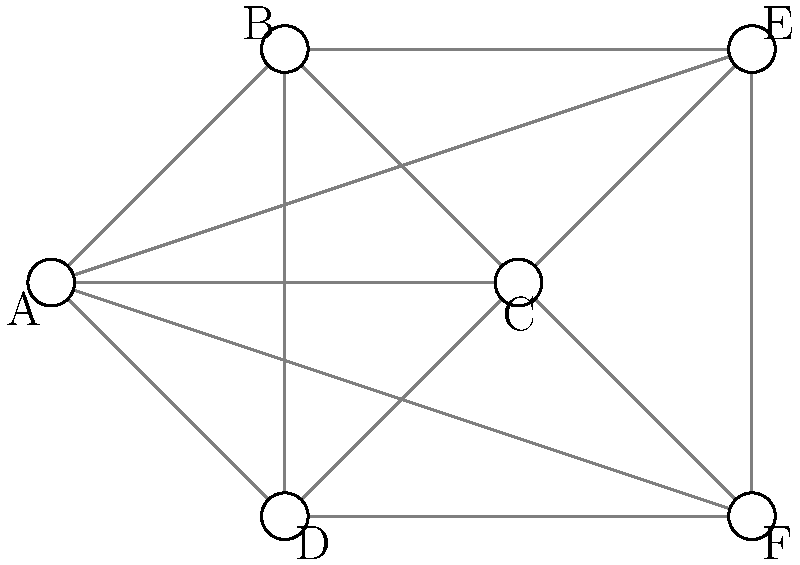In a hospital's secure mesh network for medical devices, how many minimum hops are required for data to travel from device A to device F, assuming all connections are active and equal in priority? To determine the minimum number of hops required for data to travel from device A to device F in the given mesh network topology, we need to follow these steps:

1. Identify the starting point (device A) and the destination (device F).
2. Analyze all possible paths from A to F.
3. Count the number of hops (connections) in each path.
4. Choose the path with the minimum number of hops.

Possible paths from A to F:
1. A → B → E → F (3 hops)
2. A → B → C → F (3 hops)
3. A → D → C → F (3 hops)
4. A → C → F (2 hops)

The path A → C → F requires only 2 hops, which is the minimum number of connections needed to transmit data from device A to device F in this mesh network topology.

This mesh network topology ensures redundancy and reliability in the communication between medical devices, which is crucial for maintaining data integrity and protecting sensitive patient information. If one path fails or becomes compromised, the network can quickly reroute data through alternative paths, minimizing the risk of data breaches or loss of critical medical information.
Answer: 2 hops 